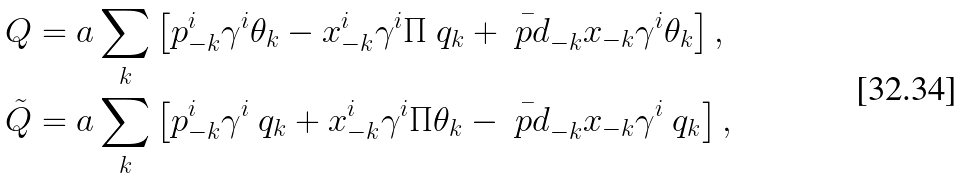Convert formula to latex. <formula><loc_0><loc_0><loc_500><loc_500>Q & = a \sum _ { k } \left [ p ^ { i } _ { - k } \gamma ^ { i } \theta _ { k } - x ^ { i } _ { - k } \gamma ^ { i } \Pi \ q _ { k } + \bar { \ p d } _ { - k } x _ { - k } \gamma ^ { i } \theta _ { k } \right ] , \\ \tilde { Q } & = a \sum _ { k } \left [ p ^ { i } _ { - k } \gamma ^ { i } \ q _ { k } + x ^ { i } _ { - k } \gamma ^ { i } \Pi \theta _ { k } - \bar { \ p d } _ { - k } x _ { - k } \gamma ^ { i } \ q _ { k } \right ] ,</formula> 